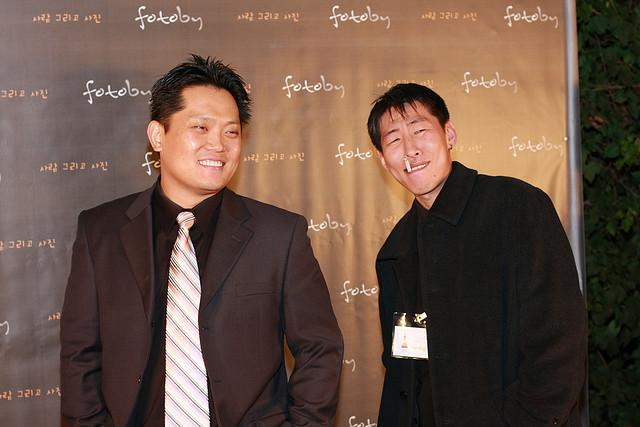Where do these people stand? red carpet 